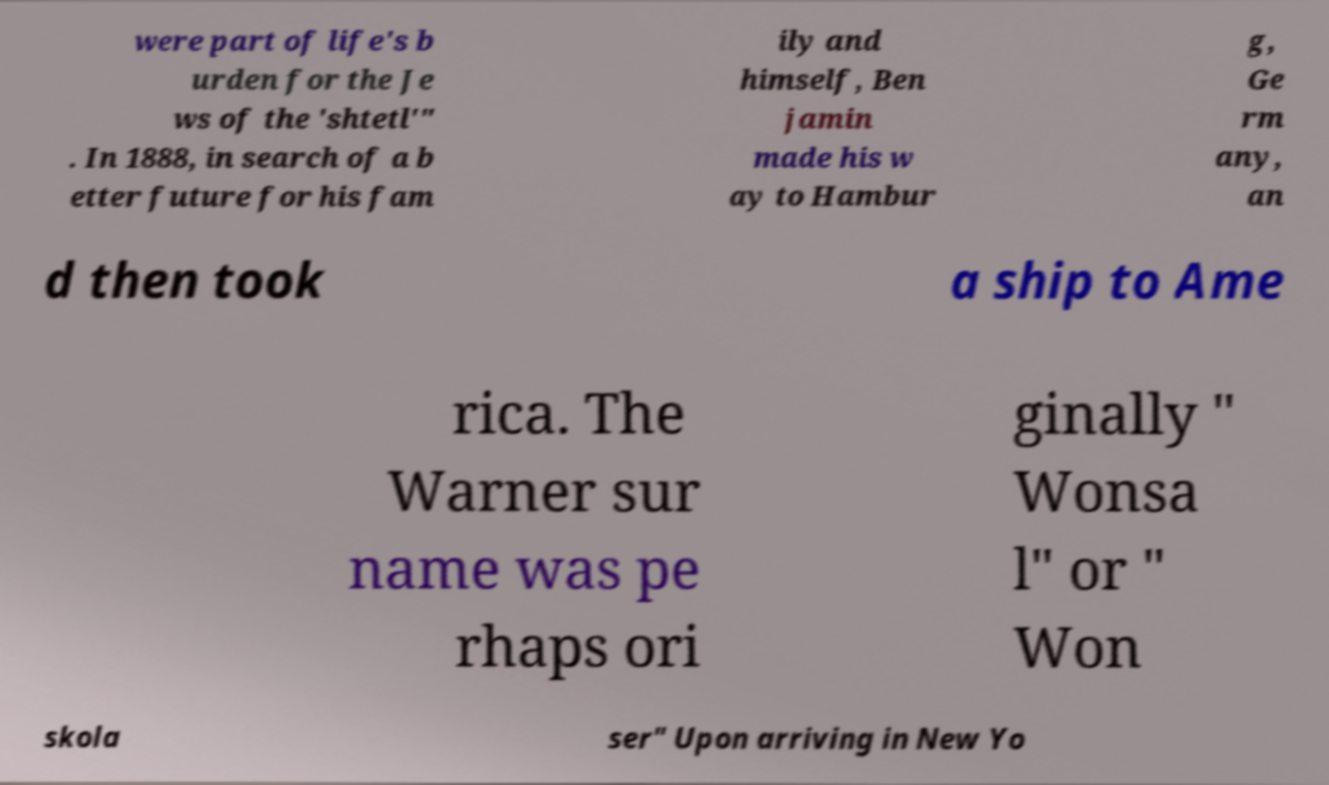I need the written content from this picture converted into text. Can you do that? were part of life's b urden for the Je ws of the 'shtetl'" . In 1888, in search of a b etter future for his fam ily and himself, Ben jamin made his w ay to Hambur g, Ge rm any, an d then took a ship to Ame rica. The Warner sur name was pe rhaps ori ginally " Wonsa l" or " Won skola ser" Upon arriving in New Yo 